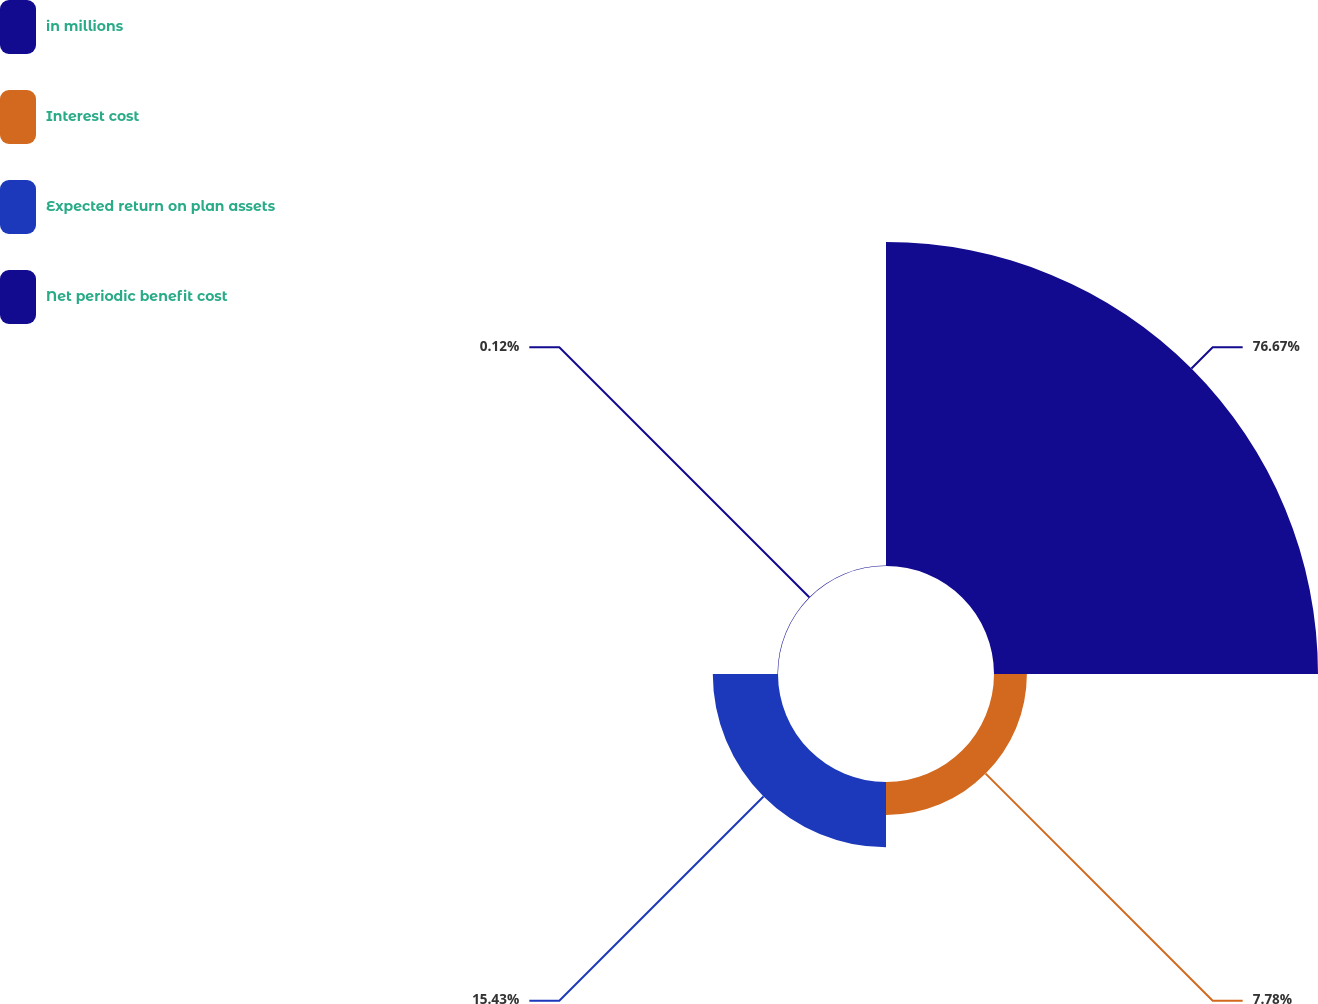<chart> <loc_0><loc_0><loc_500><loc_500><pie_chart><fcel>in millions<fcel>Interest cost<fcel>Expected return on plan assets<fcel>Net periodic benefit cost<nl><fcel>76.67%<fcel>7.78%<fcel>15.43%<fcel>0.12%<nl></chart> 